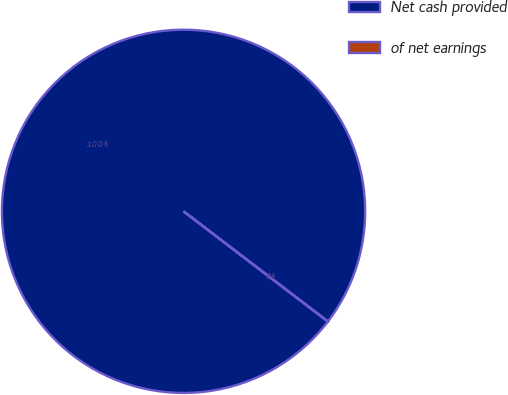Convert chart to OTSL. <chart><loc_0><loc_0><loc_500><loc_500><pie_chart><fcel>Net cash provided<fcel>of net earnings<nl><fcel>99.98%<fcel>0.02%<nl></chart> 